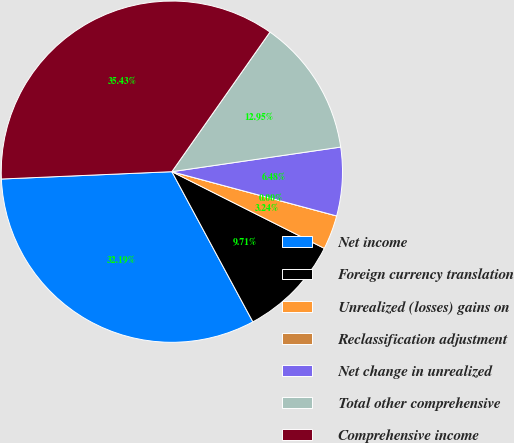<chart> <loc_0><loc_0><loc_500><loc_500><pie_chart><fcel>Net income<fcel>Foreign currency translation<fcel>Unrealized (losses) gains on<fcel>Reclassification adjustment<fcel>Net change in unrealized<fcel>Total other comprehensive<fcel>Comprehensive income<nl><fcel>32.19%<fcel>9.71%<fcel>3.24%<fcel>0.0%<fcel>6.48%<fcel>12.95%<fcel>35.43%<nl></chart> 